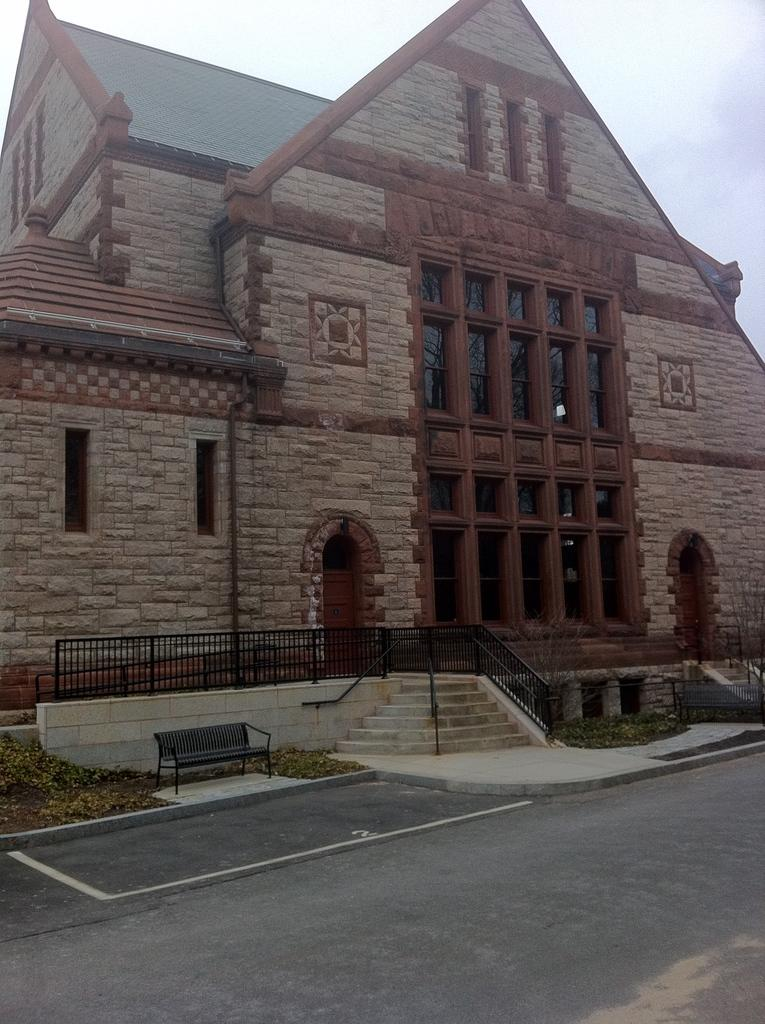What type of structure is visible in the image? There is a building in the image. What features can be seen on the building? The building has windows, doors, and a roof. What other objects are present in the image? There is a fence, a staircase, plants, benches, and a pathway. What is visible in the background of the image? The sky is visible in the image, and it appears to be cloudy. How does the thumb adjust the battle in the image? There is no thumb or battle present in the image. 